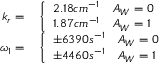Convert formula to latex. <formula><loc_0><loc_0><loc_500><loc_500>\begin{array} { r l } { k _ { r } = } & \left \{ \begin{array} { l l } { 2 . 1 8 c m ^ { - 1 } } & { A _ { W } = 0 } \\ { 1 . 8 7 c m ^ { - 1 } } & { A _ { W } = 1 } \end{array} } \\ { \omega _ { 1 } = } & \left \{ \begin{array} { l l } { \pm 6 3 9 0 s ^ { - 1 } } & { A _ { W } = 0 } \\ { \pm 4 4 6 0 s ^ { - 1 } } & { A _ { W } = 1 } \end{array} } \end{array}</formula> 